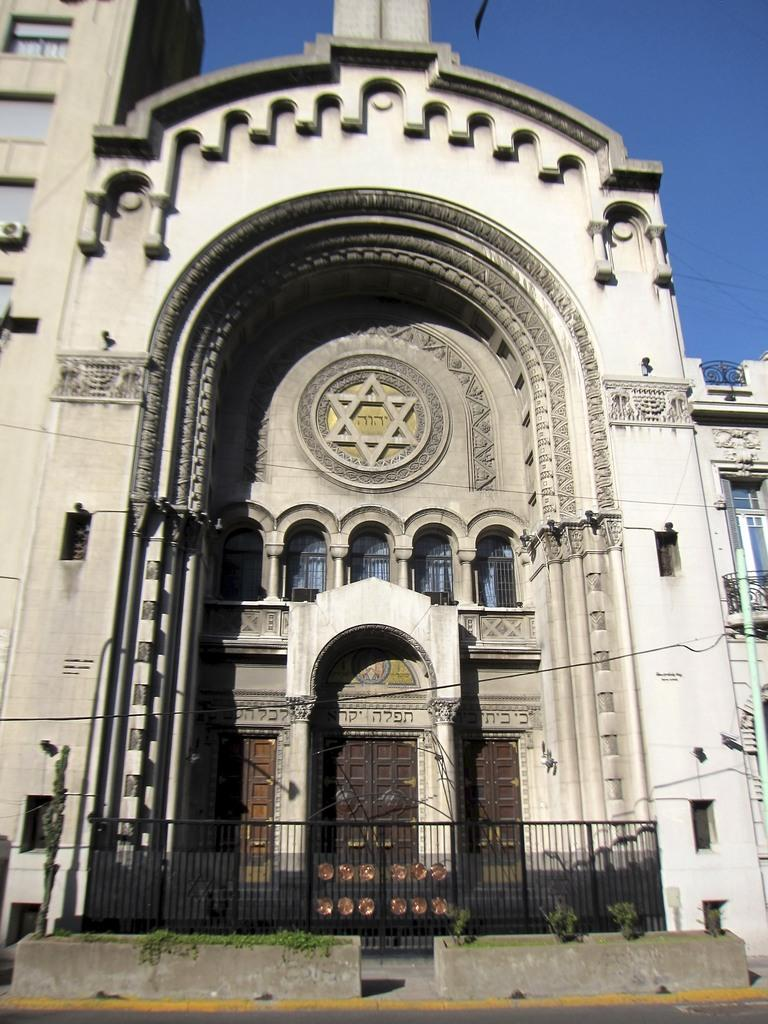What is located in the foreground of the image? There is a railing and a building in the foreground of the image. What can be seen at the top of the image? The sky is visible at the top of the image. What sound can be heard coming from the trucks in the image? There are no trucks present in the image, so it is not possible to determine what sound might be heard. 